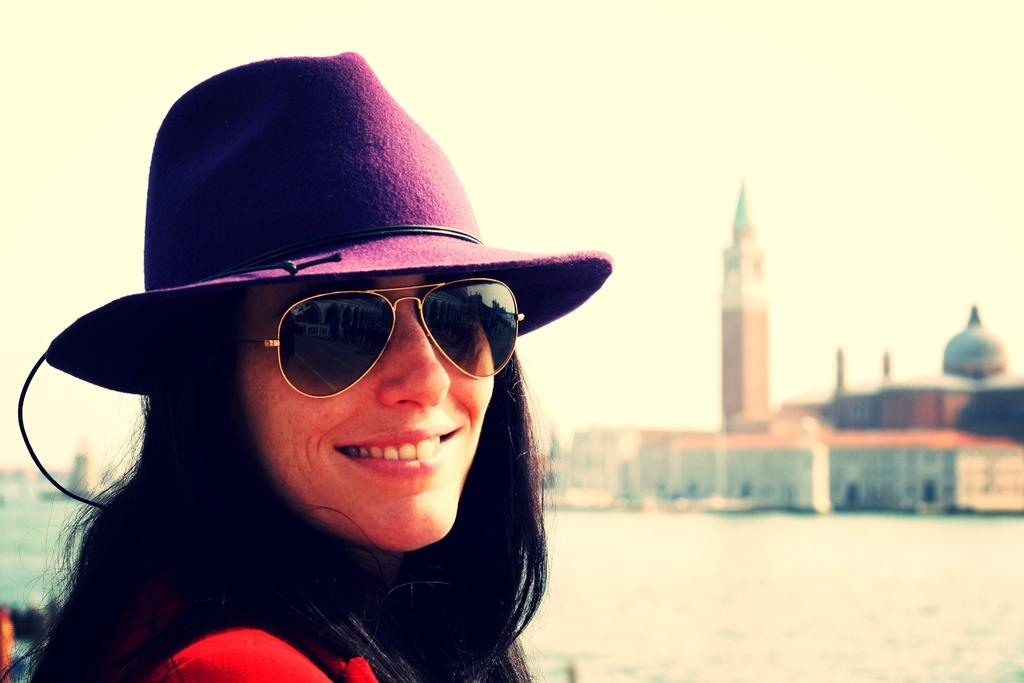Who is the main subject in the image? There is a lady in the image. What is the lady wearing on her face? The lady is wearing goggles. What type of headwear is the lady wearing? The lady is wearing a hat. What is the lady's facial expression? The lady is smiling. What can be seen in the background of the image? There is water, a building, and the sky visible in the background of the image. What direction is the worm crawling in the image? There is no worm present in the image, so it is not possible to determine the direction in which it might be crawling. 